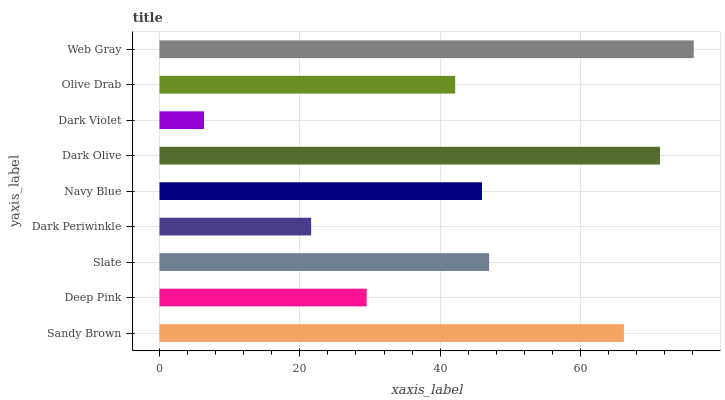Is Dark Violet the minimum?
Answer yes or no. Yes. Is Web Gray the maximum?
Answer yes or no. Yes. Is Deep Pink the minimum?
Answer yes or no. No. Is Deep Pink the maximum?
Answer yes or no. No. Is Sandy Brown greater than Deep Pink?
Answer yes or no. Yes. Is Deep Pink less than Sandy Brown?
Answer yes or no. Yes. Is Deep Pink greater than Sandy Brown?
Answer yes or no. No. Is Sandy Brown less than Deep Pink?
Answer yes or no. No. Is Navy Blue the high median?
Answer yes or no. Yes. Is Navy Blue the low median?
Answer yes or no. Yes. Is Dark Periwinkle the high median?
Answer yes or no. No. Is Deep Pink the low median?
Answer yes or no. No. 